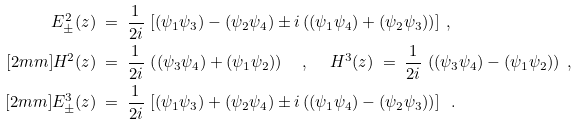Convert formula to latex. <formula><loc_0><loc_0><loc_500><loc_500>E ^ { 2 } _ { \pm } ( z ) & \ = \ \frac { 1 } { 2 i } \, \left [ ( \psi _ { 1 } \psi _ { 3 } ) - ( \psi _ { 2 } \psi _ { 4 } ) \pm i \left ( ( \psi _ { 1 } \psi _ { 4 } ) + ( \psi _ { 2 } \psi _ { 3 } ) \right ) \right ] \ , \\ [ 2 m m ] H ^ { 2 } ( z ) & \ = \ \frac { 1 } { 2 i } \, \left ( ( \psi _ { 3 } \psi _ { 4 } ) + ( \psi _ { 1 } \psi _ { 2 } ) \right ) \quad , \quad \ H ^ { 3 } ( z ) \ = \ \frac { 1 } { 2 i } \, \left ( ( \psi _ { 3 } \psi _ { 4 } ) - ( \psi _ { 1 } \psi _ { 2 } ) \right ) \ , \\ [ 2 m m ] E ^ { 3 } _ { \pm } ( z ) & \ = \ \frac { 1 } { 2 i } \, \left [ ( \psi _ { 1 } \psi _ { 3 } ) + ( \psi _ { 2 } \psi _ { 4 } ) \pm i \left ( ( \psi _ { 1 } \psi _ { 4 } ) - ( \psi _ { 2 } \psi _ { 3 } ) \right ) \right ] \ \ .</formula> 